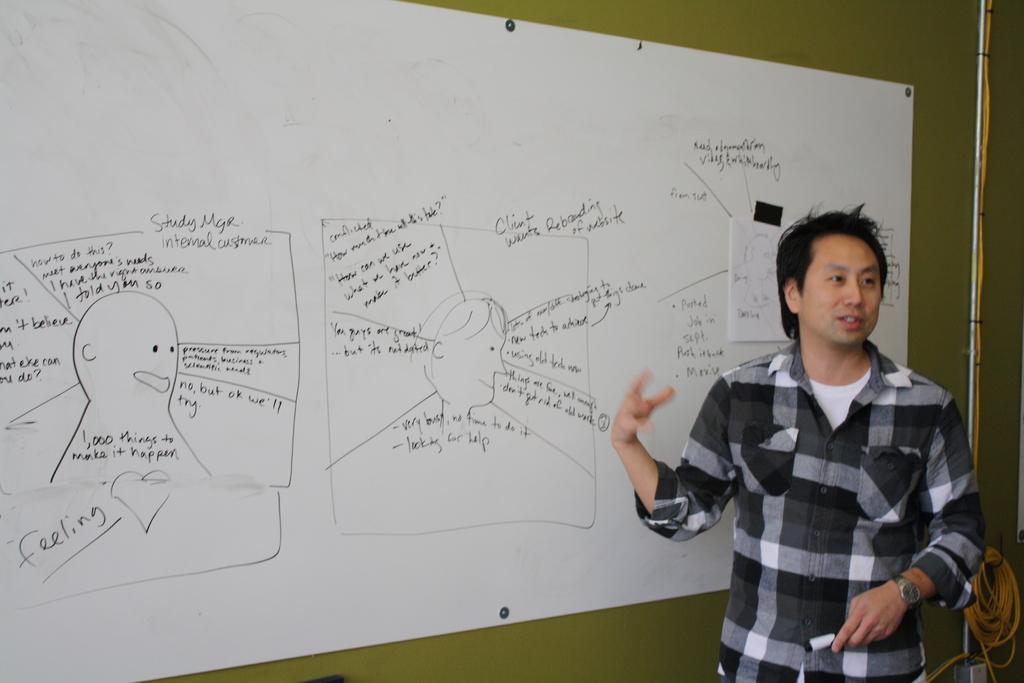How would you summarize this image in a sentence or two? There is a man standing and talking and we can see board on a wall. Behind this man we can see rod and rope. 